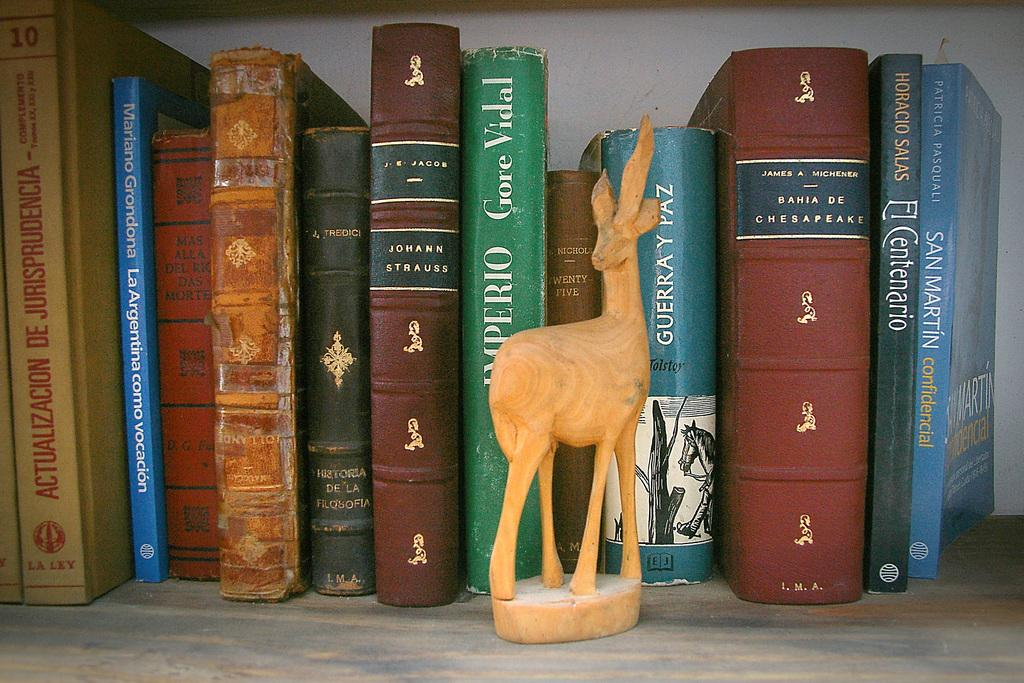<image>
Create a compact narrative representing the image presented. A collection of books includes one by Gore Vidal. 